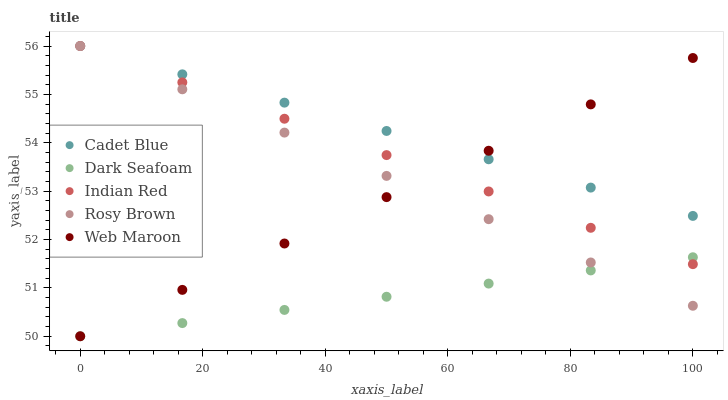Does Dark Seafoam have the minimum area under the curve?
Answer yes or no. Yes. Does Cadet Blue have the maximum area under the curve?
Answer yes or no. Yes. Does Cadet Blue have the minimum area under the curve?
Answer yes or no. No. Does Dark Seafoam have the maximum area under the curve?
Answer yes or no. No. Is Cadet Blue the smoothest?
Answer yes or no. Yes. Is Dark Seafoam the roughest?
Answer yes or no. Yes. Is Dark Seafoam the smoothest?
Answer yes or no. No. Is Cadet Blue the roughest?
Answer yes or no. No. Does Web Maroon have the lowest value?
Answer yes or no. Yes. Does Cadet Blue have the lowest value?
Answer yes or no. No. Does Indian Red have the highest value?
Answer yes or no. Yes. Does Dark Seafoam have the highest value?
Answer yes or no. No. Is Dark Seafoam less than Cadet Blue?
Answer yes or no. Yes. Is Cadet Blue greater than Dark Seafoam?
Answer yes or no. Yes. Does Rosy Brown intersect Web Maroon?
Answer yes or no. Yes. Is Rosy Brown less than Web Maroon?
Answer yes or no. No. Is Rosy Brown greater than Web Maroon?
Answer yes or no. No. Does Dark Seafoam intersect Cadet Blue?
Answer yes or no. No. 